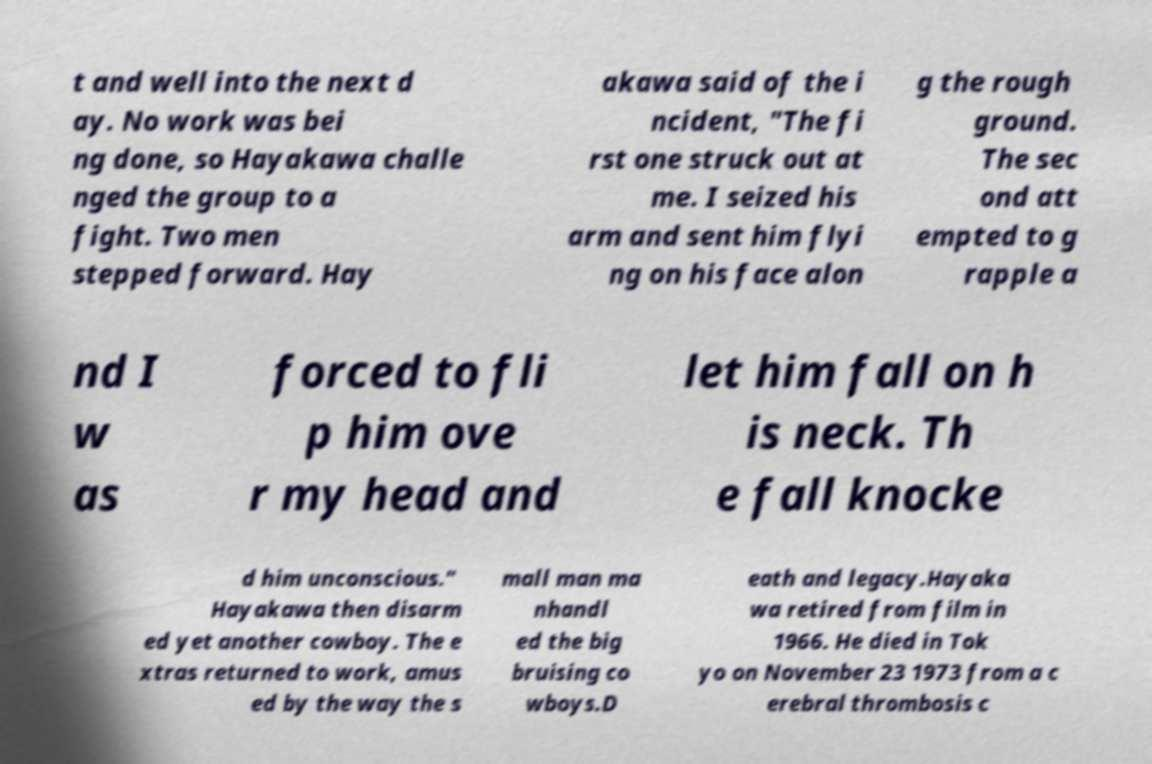Can you accurately transcribe the text from the provided image for me? t and well into the next d ay. No work was bei ng done, so Hayakawa challe nged the group to a fight. Two men stepped forward. Hay akawa said of the i ncident, "The fi rst one struck out at me. I seized his arm and sent him flyi ng on his face alon g the rough ground. The sec ond att empted to g rapple a nd I w as forced to fli p him ove r my head and let him fall on h is neck. Th e fall knocke d him unconscious." Hayakawa then disarm ed yet another cowboy. The e xtras returned to work, amus ed by the way the s mall man ma nhandl ed the big bruising co wboys.D eath and legacy.Hayaka wa retired from film in 1966. He died in Tok yo on November 23 1973 from a c erebral thrombosis c 